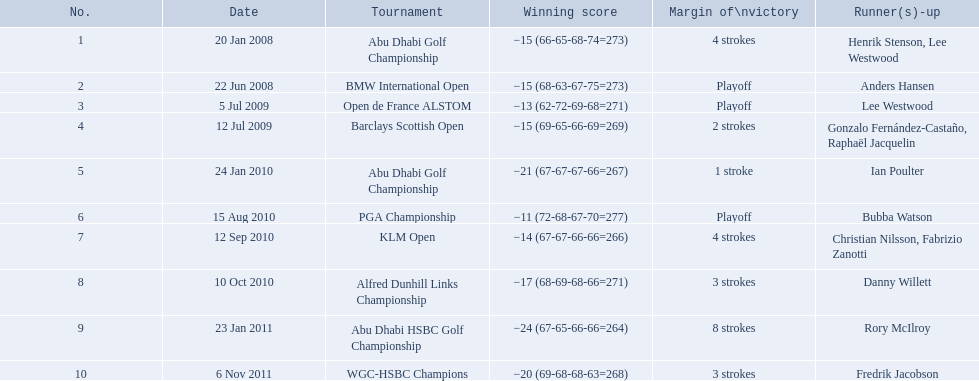Which tournaments did martin kaymer participate in? Abu Dhabi Golf Championship, BMW International Open, Open de France ALSTOM, Barclays Scottish Open, Abu Dhabi Golf Championship, PGA Championship, KLM Open, Alfred Dunhill Links Championship, Abu Dhabi HSBC Golf Championship, WGC-HSBC Champions. How many of these tournaments were won through a playoff? BMW International Open, Open de France ALSTOM, PGA Championship. Which of those tournaments took place in 2010? PGA Championship. Who had to top score next to martin kaymer for that tournament? Bubba Watson. 